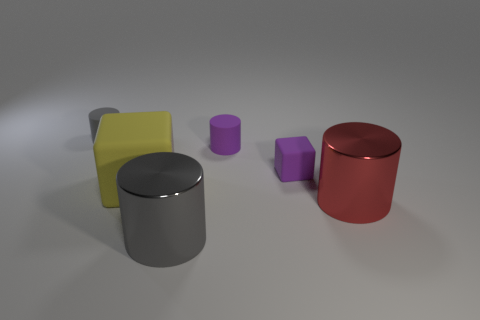How many big things are either gray objects or cubes?
Your answer should be very brief. 2. Are there any small purple objects left of the big shiny thing that is right of the purple rubber cylinder?
Provide a succinct answer. Yes. Are there any tiny green cylinders?
Your answer should be very brief. No. The matte cylinder that is to the right of the gray object that is behind the large rubber object is what color?
Make the answer very short. Purple. What is the material of the tiny gray object that is the same shape as the big red thing?
Your answer should be very brief. Rubber. What number of shiny cylinders have the same size as the yellow rubber cube?
Make the answer very short. 2. The gray object that is the same material as the large red object is what size?
Your response must be concise. Large. What number of other metal objects have the same shape as the large red shiny thing?
Give a very brief answer. 1. How many large cubes are there?
Your answer should be very brief. 1. Do the small purple rubber object that is in front of the purple cylinder and the red shiny thing have the same shape?
Your answer should be very brief. No. 